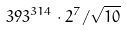Convert formula to latex. <formula><loc_0><loc_0><loc_500><loc_500>3 9 3 ^ { 3 1 4 } \cdot 2 ^ { 7 } / \sqrt { 1 0 }</formula> 